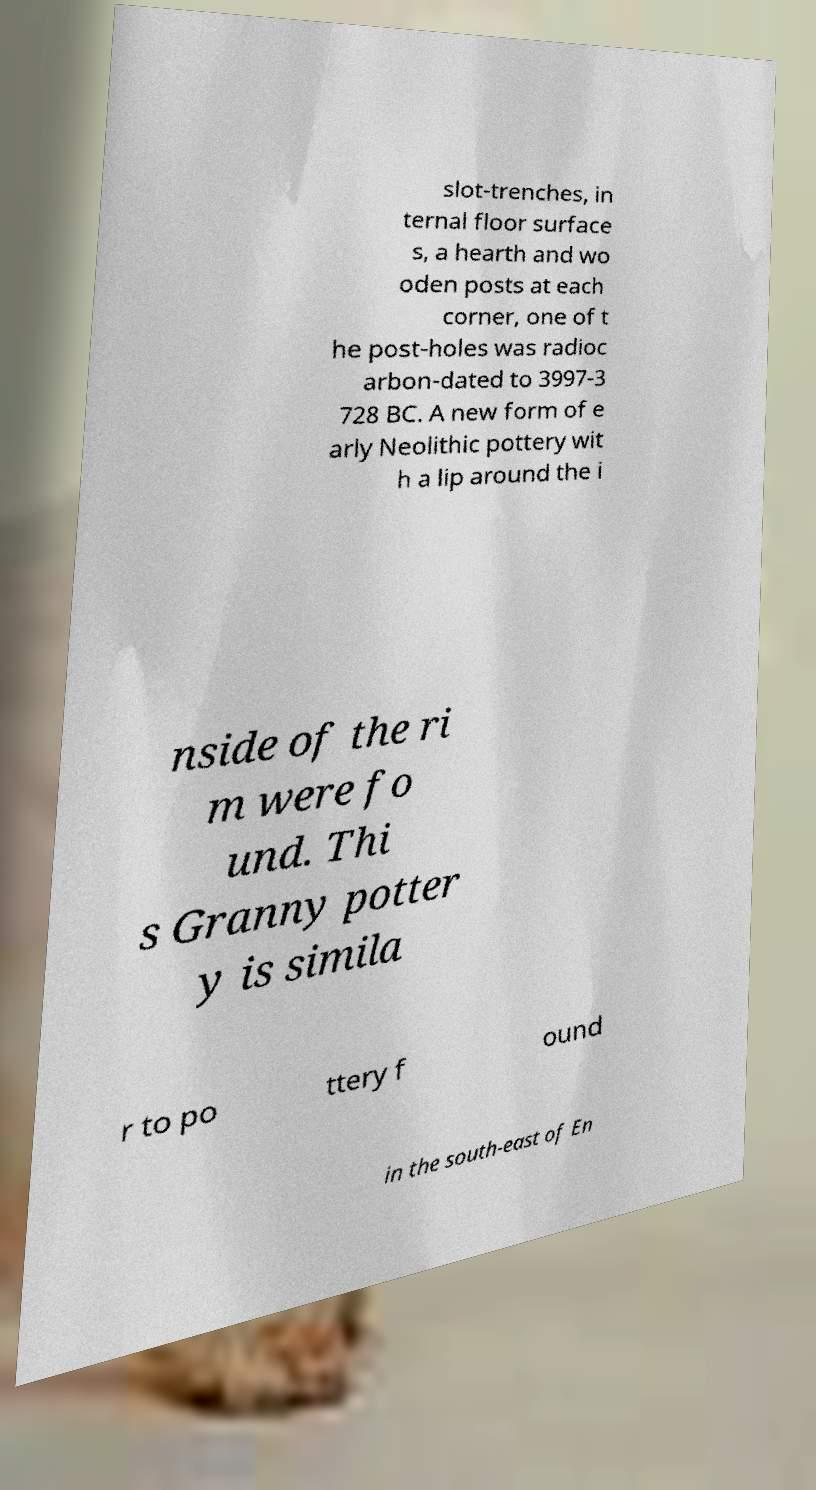What messages or text are displayed in this image? I need them in a readable, typed format. slot-trenches, in ternal floor surface s, a hearth and wo oden posts at each corner, one of t he post-holes was radioc arbon-dated to 3997-3 728 BC. A new form of e arly Neolithic pottery wit h a lip around the i nside of the ri m were fo und. Thi s Granny potter y is simila r to po ttery f ound in the south-east of En 